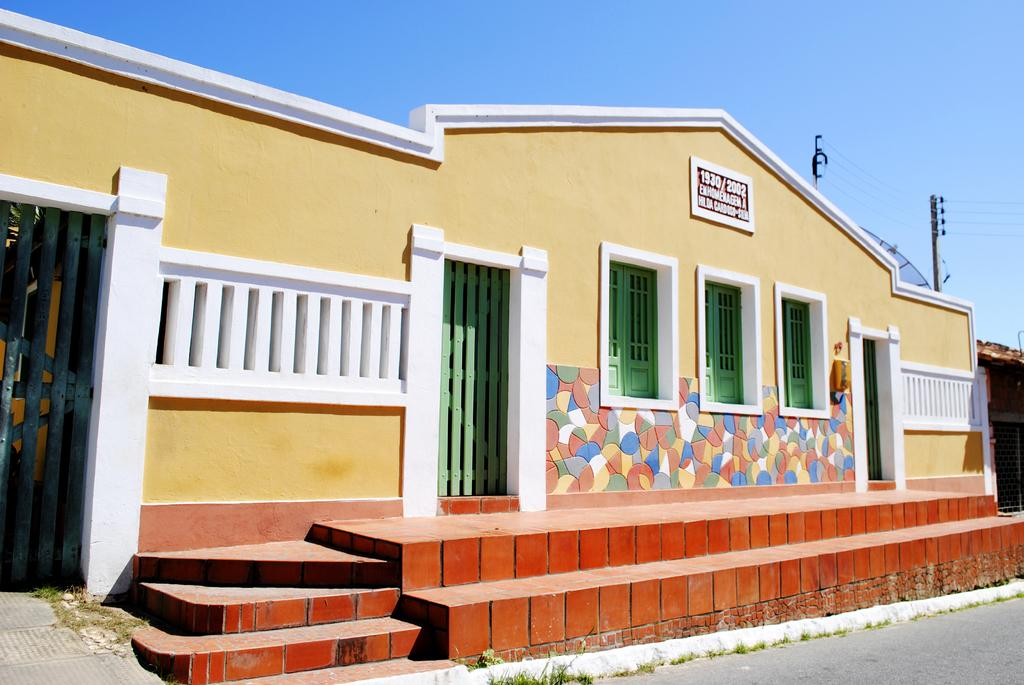What is the main subject of the image? There is a house in the center of the image. Can you describe the house in the image? The provided facts do not give any details about the house's appearance or features. Is there anything else visible in the image besides the house? The provided facts do not mention any other objects or subjects in the image. Is there a volcano in the house's stomach in the image? There is no mention of a volcano or a house's stomach in the provided facts, and therefore no such scenario can be observed in the image. 